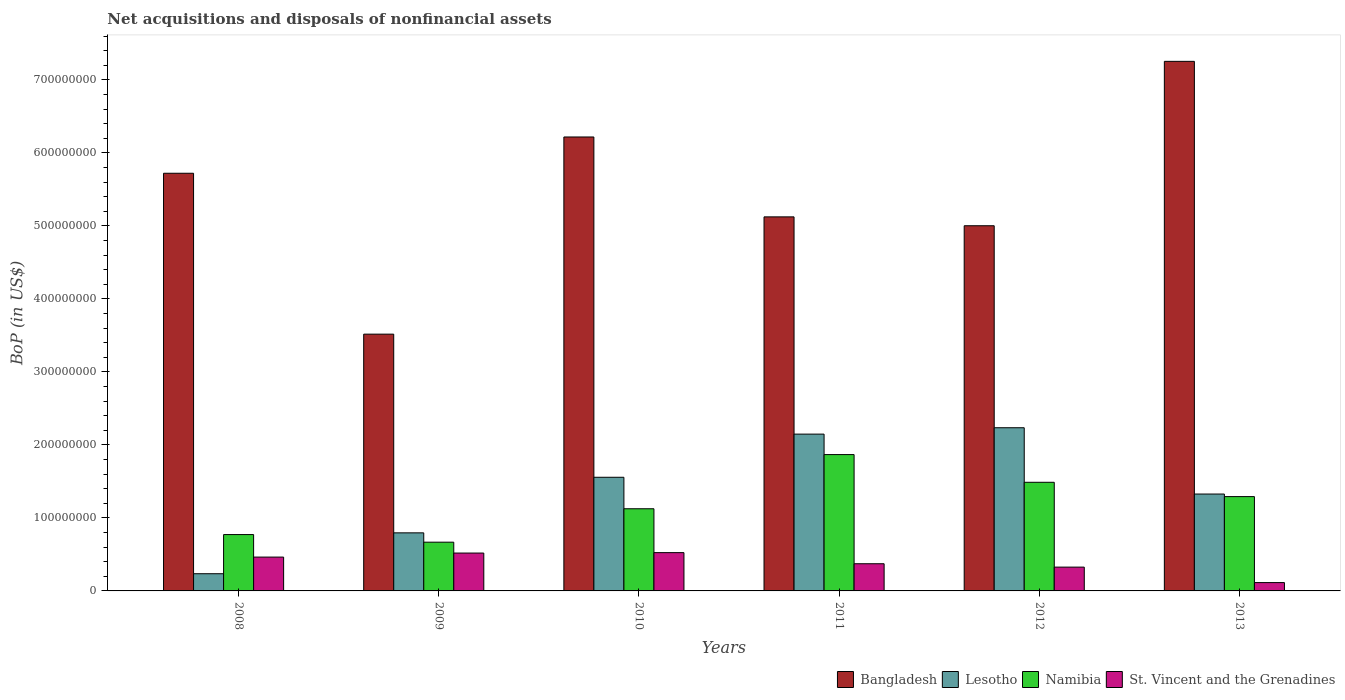How many different coloured bars are there?
Your answer should be very brief. 4. How many bars are there on the 4th tick from the left?
Provide a short and direct response. 4. What is the Balance of Payments in Bangladesh in 2009?
Give a very brief answer. 3.52e+08. Across all years, what is the maximum Balance of Payments in Bangladesh?
Your answer should be very brief. 7.25e+08. Across all years, what is the minimum Balance of Payments in St. Vincent and the Grenadines?
Your response must be concise. 1.14e+07. In which year was the Balance of Payments in St. Vincent and the Grenadines maximum?
Ensure brevity in your answer.  2010. What is the total Balance of Payments in Namibia in the graph?
Provide a short and direct response. 7.21e+08. What is the difference between the Balance of Payments in Bangladesh in 2011 and that in 2013?
Your answer should be very brief. -2.13e+08. What is the difference between the Balance of Payments in Namibia in 2011 and the Balance of Payments in Lesotho in 2012?
Ensure brevity in your answer.  -3.68e+07. What is the average Balance of Payments in Bangladesh per year?
Your response must be concise. 5.47e+08. In the year 2010, what is the difference between the Balance of Payments in Namibia and Balance of Payments in Lesotho?
Provide a succinct answer. -4.31e+07. In how many years, is the Balance of Payments in Lesotho greater than 620000000 US$?
Keep it short and to the point. 0. What is the ratio of the Balance of Payments in St. Vincent and the Grenadines in 2010 to that in 2011?
Offer a terse response. 1.41. Is the difference between the Balance of Payments in Namibia in 2009 and 2011 greater than the difference between the Balance of Payments in Lesotho in 2009 and 2011?
Give a very brief answer. Yes. What is the difference between the highest and the second highest Balance of Payments in St. Vincent and the Grenadines?
Offer a terse response. 5.84e+05. What is the difference between the highest and the lowest Balance of Payments in St. Vincent and the Grenadines?
Ensure brevity in your answer.  4.10e+07. In how many years, is the Balance of Payments in Lesotho greater than the average Balance of Payments in Lesotho taken over all years?
Your answer should be compact. 3. What does the 3rd bar from the left in 2013 represents?
Your answer should be very brief. Namibia. What does the 4th bar from the right in 2010 represents?
Give a very brief answer. Bangladesh. Are the values on the major ticks of Y-axis written in scientific E-notation?
Give a very brief answer. No. Does the graph contain grids?
Offer a terse response. No. How many legend labels are there?
Offer a very short reply. 4. How are the legend labels stacked?
Keep it short and to the point. Horizontal. What is the title of the graph?
Provide a short and direct response. Net acquisitions and disposals of nonfinancial assets. Does "Central African Republic" appear as one of the legend labels in the graph?
Your response must be concise. No. What is the label or title of the X-axis?
Give a very brief answer. Years. What is the label or title of the Y-axis?
Your answer should be very brief. BoP (in US$). What is the BoP (in US$) of Bangladesh in 2008?
Offer a terse response. 5.72e+08. What is the BoP (in US$) in Lesotho in 2008?
Your response must be concise. 2.36e+07. What is the BoP (in US$) in Namibia in 2008?
Provide a short and direct response. 7.72e+07. What is the BoP (in US$) in St. Vincent and the Grenadines in 2008?
Make the answer very short. 4.63e+07. What is the BoP (in US$) of Bangladesh in 2009?
Make the answer very short. 3.52e+08. What is the BoP (in US$) in Lesotho in 2009?
Make the answer very short. 7.96e+07. What is the BoP (in US$) of Namibia in 2009?
Keep it short and to the point. 6.68e+07. What is the BoP (in US$) in St. Vincent and the Grenadines in 2009?
Provide a short and direct response. 5.19e+07. What is the BoP (in US$) in Bangladesh in 2010?
Your answer should be compact. 6.22e+08. What is the BoP (in US$) in Lesotho in 2010?
Offer a very short reply. 1.56e+08. What is the BoP (in US$) in Namibia in 2010?
Offer a terse response. 1.13e+08. What is the BoP (in US$) in St. Vincent and the Grenadines in 2010?
Offer a terse response. 5.25e+07. What is the BoP (in US$) of Bangladesh in 2011?
Provide a short and direct response. 5.12e+08. What is the BoP (in US$) of Lesotho in 2011?
Your answer should be very brief. 2.15e+08. What is the BoP (in US$) of Namibia in 2011?
Your answer should be compact. 1.87e+08. What is the BoP (in US$) in St. Vincent and the Grenadines in 2011?
Your response must be concise. 3.72e+07. What is the BoP (in US$) in Bangladesh in 2012?
Make the answer very short. 5.00e+08. What is the BoP (in US$) in Lesotho in 2012?
Your answer should be compact. 2.24e+08. What is the BoP (in US$) in Namibia in 2012?
Your answer should be compact. 1.49e+08. What is the BoP (in US$) of St. Vincent and the Grenadines in 2012?
Provide a succinct answer. 3.26e+07. What is the BoP (in US$) of Bangladesh in 2013?
Your response must be concise. 7.25e+08. What is the BoP (in US$) of Lesotho in 2013?
Keep it short and to the point. 1.33e+08. What is the BoP (in US$) in Namibia in 2013?
Give a very brief answer. 1.29e+08. What is the BoP (in US$) of St. Vincent and the Grenadines in 2013?
Your response must be concise. 1.14e+07. Across all years, what is the maximum BoP (in US$) of Bangladesh?
Your answer should be very brief. 7.25e+08. Across all years, what is the maximum BoP (in US$) of Lesotho?
Offer a terse response. 2.24e+08. Across all years, what is the maximum BoP (in US$) of Namibia?
Keep it short and to the point. 1.87e+08. Across all years, what is the maximum BoP (in US$) in St. Vincent and the Grenadines?
Make the answer very short. 5.25e+07. Across all years, what is the minimum BoP (in US$) in Bangladesh?
Offer a very short reply. 3.52e+08. Across all years, what is the minimum BoP (in US$) of Lesotho?
Provide a short and direct response. 2.36e+07. Across all years, what is the minimum BoP (in US$) of Namibia?
Your response must be concise. 6.68e+07. Across all years, what is the minimum BoP (in US$) of St. Vincent and the Grenadines?
Provide a short and direct response. 1.14e+07. What is the total BoP (in US$) in Bangladesh in the graph?
Ensure brevity in your answer.  3.28e+09. What is the total BoP (in US$) of Lesotho in the graph?
Ensure brevity in your answer.  8.30e+08. What is the total BoP (in US$) of Namibia in the graph?
Give a very brief answer. 7.21e+08. What is the total BoP (in US$) of St. Vincent and the Grenadines in the graph?
Your answer should be compact. 2.32e+08. What is the difference between the BoP (in US$) of Bangladesh in 2008 and that in 2009?
Provide a short and direct response. 2.20e+08. What is the difference between the BoP (in US$) in Lesotho in 2008 and that in 2009?
Offer a terse response. -5.60e+07. What is the difference between the BoP (in US$) of Namibia in 2008 and that in 2009?
Your answer should be compact. 1.04e+07. What is the difference between the BoP (in US$) of St. Vincent and the Grenadines in 2008 and that in 2009?
Make the answer very short. -5.53e+06. What is the difference between the BoP (in US$) of Bangladesh in 2008 and that in 2010?
Keep it short and to the point. -4.97e+07. What is the difference between the BoP (in US$) in Lesotho in 2008 and that in 2010?
Provide a succinct answer. -1.32e+08. What is the difference between the BoP (in US$) in Namibia in 2008 and that in 2010?
Provide a short and direct response. -3.54e+07. What is the difference between the BoP (in US$) in St. Vincent and the Grenadines in 2008 and that in 2010?
Provide a succinct answer. -6.12e+06. What is the difference between the BoP (in US$) in Bangladesh in 2008 and that in 2011?
Give a very brief answer. 5.98e+07. What is the difference between the BoP (in US$) of Lesotho in 2008 and that in 2011?
Offer a very short reply. -1.91e+08. What is the difference between the BoP (in US$) of Namibia in 2008 and that in 2011?
Keep it short and to the point. -1.10e+08. What is the difference between the BoP (in US$) of St. Vincent and the Grenadines in 2008 and that in 2011?
Offer a very short reply. 9.11e+06. What is the difference between the BoP (in US$) in Bangladesh in 2008 and that in 2012?
Give a very brief answer. 7.19e+07. What is the difference between the BoP (in US$) of Lesotho in 2008 and that in 2012?
Make the answer very short. -2.00e+08. What is the difference between the BoP (in US$) in Namibia in 2008 and that in 2012?
Your answer should be compact. -7.16e+07. What is the difference between the BoP (in US$) of St. Vincent and the Grenadines in 2008 and that in 2012?
Keep it short and to the point. 1.37e+07. What is the difference between the BoP (in US$) of Bangladesh in 2008 and that in 2013?
Give a very brief answer. -1.53e+08. What is the difference between the BoP (in US$) in Lesotho in 2008 and that in 2013?
Provide a succinct answer. -1.09e+08. What is the difference between the BoP (in US$) of Namibia in 2008 and that in 2013?
Make the answer very short. -5.20e+07. What is the difference between the BoP (in US$) of St. Vincent and the Grenadines in 2008 and that in 2013?
Provide a short and direct response. 3.49e+07. What is the difference between the BoP (in US$) in Bangladesh in 2009 and that in 2010?
Give a very brief answer. -2.70e+08. What is the difference between the BoP (in US$) of Lesotho in 2009 and that in 2010?
Your response must be concise. -7.61e+07. What is the difference between the BoP (in US$) of Namibia in 2009 and that in 2010?
Your response must be concise. -4.58e+07. What is the difference between the BoP (in US$) of St. Vincent and the Grenadines in 2009 and that in 2010?
Make the answer very short. -5.84e+05. What is the difference between the BoP (in US$) in Bangladesh in 2009 and that in 2011?
Your response must be concise. -1.61e+08. What is the difference between the BoP (in US$) in Lesotho in 2009 and that in 2011?
Provide a short and direct response. -1.35e+08. What is the difference between the BoP (in US$) in Namibia in 2009 and that in 2011?
Make the answer very short. -1.20e+08. What is the difference between the BoP (in US$) of St. Vincent and the Grenadines in 2009 and that in 2011?
Make the answer very short. 1.46e+07. What is the difference between the BoP (in US$) of Bangladesh in 2009 and that in 2012?
Give a very brief answer. -1.48e+08. What is the difference between the BoP (in US$) in Lesotho in 2009 and that in 2012?
Make the answer very short. -1.44e+08. What is the difference between the BoP (in US$) in Namibia in 2009 and that in 2012?
Keep it short and to the point. -8.21e+07. What is the difference between the BoP (in US$) of St. Vincent and the Grenadines in 2009 and that in 2012?
Give a very brief answer. 1.93e+07. What is the difference between the BoP (in US$) in Bangladesh in 2009 and that in 2013?
Provide a short and direct response. -3.74e+08. What is the difference between the BoP (in US$) in Lesotho in 2009 and that in 2013?
Your answer should be very brief. -5.32e+07. What is the difference between the BoP (in US$) in Namibia in 2009 and that in 2013?
Provide a short and direct response. -6.24e+07. What is the difference between the BoP (in US$) in St. Vincent and the Grenadines in 2009 and that in 2013?
Your answer should be very brief. 4.05e+07. What is the difference between the BoP (in US$) in Bangladesh in 2010 and that in 2011?
Provide a succinct answer. 1.09e+08. What is the difference between the BoP (in US$) of Lesotho in 2010 and that in 2011?
Keep it short and to the point. -5.91e+07. What is the difference between the BoP (in US$) in Namibia in 2010 and that in 2011?
Offer a terse response. -7.42e+07. What is the difference between the BoP (in US$) in St. Vincent and the Grenadines in 2010 and that in 2011?
Make the answer very short. 1.52e+07. What is the difference between the BoP (in US$) in Bangladesh in 2010 and that in 2012?
Keep it short and to the point. 1.22e+08. What is the difference between the BoP (in US$) in Lesotho in 2010 and that in 2012?
Keep it short and to the point. -6.79e+07. What is the difference between the BoP (in US$) in Namibia in 2010 and that in 2012?
Offer a very short reply. -3.63e+07. What is the difference between the BoP (in US$) of St. Vincent and the Grenadines in 2010 and that in 2012?
Your answer should be compact. 1.98e+07. What is the difference between the BoP (in US$) in Bangladesh in 2010 and that in 2013?
Make the answer very short. -1.04e+08. What is the difference between the BoP (in US$) of Lesotho in 2010 and that in 2013?
Offer a terse response. 2.30e+07. What is the difference between the BoP (in US$) of Namibia in 2010 and that in 2013?
Give a very brief answer. -1.66e+07. What is the difference between the BoP (in US$) in St. Vincent and the Grenadines in 2010 and that in 2013?
Provide a succinct answer. 4.10e+07. What is the difference between the BoP (in US$) of Bangladesh in 2011 and that in 2012?
Your answer should be very brief. 1.21e+07. What is the difference between the BoP (in US$) of Lesotho in 2011 and that in 2012?
Your answer should be compact. -8.74e+06. What is the difference between the BoP (in US$) of Namibia in 2011 and that in 2012?
Keep it short and to the point. 3.79e+07. What is the difference between the BoP (in US$) in St. Vincent and the Grenadines in 2011 and that in 2012?
Make the answer very short. 4.62e+06. What is the difference between the BoP (in US$) in Bangladesh in 2011 and that in 2013?
Your answer should be very brief. -2.13e+08. What is the difference between the BoP (in US$) in Lesotho in 2011 and that in 2013?
Keep it short and to the point. 8.21e+07. What is the difference between the BoP (in US$) of Namibia in 2011 and that in 2013?
Offer a terse response. 5.76e+07. What is the difference between the BoP (in US$) of St. Vincent and the Grenadines in 2011 and that in 2013?
Keep it short and to the point. 2.58e+07. What is the difference between the BoP (in US$) of Bangladesh in 2012 and that in 2013?
Offer a terse response. -2.25e+08. What is the difference between the BoP (in US$) of Lesotho in 2012 and that in 2013?
Keep it short and to the point. 9.08e+07. What is the difference between the BoP (in US$) in Namibia in 2012 and that in 2013?
Your answer should be very brief. 1.96e+07. What is the difference between the BoP (in US$) in St. Vincent and the Grenadines in 2012 and that in 2013?
Give a very brief answer. 2.12e+07. What is the difference between the BoP (in US$) in Bangladesh in 2008 and the BoP (in US$) in Lesotho in 2009?
Your answer should be compact. 4.93e+08. What is the difference between the BoP (in US$) of Bangladesh in 2008 and the BoP (in US$) of Namibia in 2009?
Keep it short and to the point. 5.05e+08. What is the difference between the BoP (in US$) in Bangladesh in 2008 and the BoP (in US$) in St. Vincent and the Grenadines in 2009?
Offer a very short reply. 5.20e+08. What is the difference between the BoP (in US$) of Lesotho in 2008 and the BoP (in US$) of Namibia in 2009?
Offer a terse response. -4.32e+07. What is the difference between the BoP (in US$) in Lesotho in 2008 and the BoP (in US$) in St. Vincent and the Grenadines in 2009?
Make the answer very short. -2.83e+07. What is the difference between the BoP (in US$) of Namibia in 2008 and the BoP (in US$) of St. Vincent and the Grenadines in 2009?
Offer a very short reply. 2.53e+07. What is the difference between the BoP (in US$) in Bangladesh in 2008 and the BoP (in US$) in Lesotho in 2010?
Your answer should be compact. 4.16e+08. What is the difference between the BoP (in US$) in Bangladesh in 2008 and the BoP (in US$) in Namibia in 2010?
Provide a succinct answer. 4.60e+08. What is the difference between the BoP (in US$) in Bangladesh in 2008 and the BoP (in US$) in St. Vincent and the Grenadines in 2010?
Offer a very short reply. 5.20e+08. What is the difference between the BoP (in US$) of Lesotho in 2008 and the BoP (in US$) of Namibia in 2010?
Offer a terse response. -8.90e+07. What is the difference between the BoP (in US$) in Lesotho in 2008 and the BoP (in US$) in St. Vincent and the Grenadines in 2010?
Your response must be concise. -2.89e+07. What is the difference between the BoP (in US$) of Namibia in 2008 and the BoP (in US$) of St. Vincent and the Grenadines in 2010?
Give a very brief answer. 2.47e+07. What is the difference between the BoP (in US$) of Bangladesh in 2008 and the BoP (in US$) of Lesotho in 2011?
Offer a terse response. 3.57e+08. What is the difference between the BoP (in US$) of Bangladesh in 2008 and the BoP (in US$) of Namibia in 2011?
Your answer should be compact. 3.85e+08. What is the difference between the BoP (in US$) in Bangladesh in 2008 and the BoP (in US$) in St. Vincent and the Grenadines in 2011?
Offer a very short reply. 5.35e+08. What is the difference between the BoP (in US$) in Lesotho in 2008 and the BoP (in US$) in Namibia in 2011?
Your answer should be very brief. -1.63e+08. What is the difference between the BoP (in US$) of Lesotho in 2008 and the BoP (in US$) of St. Vincent and the Grenadines in 2011?
Provide a short and direct response. -1.37e+07. What is the difference between the BoP (in US$) of Namibia in 2008 and the BoP (in US$) of St. Vincent and the Grenadines in 2011?
Keep it short and to the point. 4.00e+07. What is the difference between the BoP (in US$) of Bangladesh in 2008 and the BoP (in US$) of Lesotho in 2012?
Provide a short and direct response. 3.49e+08. What is the difference between the BoP (in US$) of Bangladesh in 2008 and the BoP (in US$) of Namibia in 2012?
Your answer should be very brief. 4.23e+08. What is the difference between the BoP (in US$) in Bangladesh in 2008 and the BoP (in US$) in St. Vincent and the Grenadines in 2012?
Offer a very short reply. 5.40e+08. What is the difference between the BoP (in US$) in Lesotho in 2008 and the BoP (in US$) in Namibia in 2012?
Make the answer very short. -1.25e+08. What is the difference between the BoP (in US$) in Lesotho in 2008 and the BoP (in US$) in St. Vincent and the Grenadines in 2012?
Offer a terse response. -9.06e+06. What is the difference between the BoP (in US$) in Namibia in 2008 and the BoP (in US$) in St. Vincent and the Grenadines in 2012?
Ensure brevity in your answer.  4.46e+07. What is the difference between the BoP (in US$) of Bangladesh in 2008 and the BoP (in US$) of Lesotho in 2013?
Provide a succinct answer. 4.39e+08. What is the difference between the BoP (in US$) in Bangladesh in 2008 and the BoP (in US$) in Namibia in 2013?
Your answer should be compact. 4.43e+08. What is the difference between the BoP (in US$) of Bangladesh in 2008 and the BoP (in US$) of St. Vincent and the Grenadines in 2013?
Your answer should be compact. 5.61e+08. What is the difference between the BoP (in US$) in Lesotho in 2008 and the BoP (in US$) in Namibia in 2013?
Provide a succinct answer. -1.06e+08. What is the difference between the BoP (in US$) of Lesotho in 2008 and the BoP (in US$) of St. Vincent and the Grenadines in 2013?
Your answer should be very brief. 1.21e+07. What is the difference between the BoP (in US$) of Namibia in 2008 and the BoP (in US$) of St. Vincent and the Grenadines in 2013?
Your answer should be very brief. 6.58e+07. What is the difference between the BoP (in US$) of Bangladesh in 2009 and the BoP (in US$) of Lesotho in 2010?
Give a very brief answer. 1.96e+08. What is the difference between the BoP (in US$) of Bangladesh in 2009 and the BoP (in US$) of Namibia in 2010?
Provide a short and direct response. 2.39e+08. What is the difference between the BoP (in US$) of Bangladesh in 2009 and the BoP (in US$) of St. Vincent and the Grenadines in 2010?
Your answer should be compact. 2.99e+08. What is the difference between the BoP (in US$) in Lesotho in 2009 and the BoP (in US$) in Namibia in 2010?
Provide a succinct answer. -3.30e+07. What is the difference between the BoP (in US$) of Lesotho in 2009 and the BoP (in US$) of St. Vincent and the Grenadines in 2010?
Your response must be concise. 2.71e+07. What is the difference between the BoP (in US$) in Namibia in 2009 and the BoP (in US$) in St. Vincent and the Grenadines in 2010?
Ensure brevity in your answer.  1.43e+07. What is the difference between the BoP (in US$) of Bangladesh in 2009 and the BoP (in US$) of Lesotho in 2011?
Make the answer very short. 1.37e+08. What is the difference between the BoP (in US$) in Bangladesh in 2009 and the BoP (in US$) in Namibia in 2011?
Offer a very short reply. 1.65e+08. What is the difference between the BoP (in US$) in Bangladesh in 2009 and the BoP (in US$) in St. Vincent and the Grenadines in 2011?
Offer a terse response. 3.15e+08. What is the difference between the BoP (in US$) of Lesotho in 2009 and the BoP (in US$) of Namibia in 2011?
Keep it short and to the point. -1.07e+08. What is the difference between the BoP (in US$) in Lesotho in 2009 and the BoP (in US$) in St. Vincent and the Grenadines in 2011?
Make the answer very short. 4.23e+07. What is the difference between the BoP (in US$) of Namibia in 2009 and the BoP (in US$) of St. Vincent and the Grenadines in 2011?
Offer a very short reply. 2.95e+07. What is the difference between the BoP (in US$) of Bangladesh in 2009 and the BoP (in US$) of Lesotho in 2012?
Provide a short and direct response. 1.28e+08. What is the difference between the BoP (in US$) in Bangladesh in 2009 and the BoP (in US$) in Namibia in 2012?
Provide a succinct answer. 2.03e+08. What is the difference between the BoP (in US$) in Bangladesh in 2009 and the BoP (in US$) in St. Vincent and the Grenadines in 2012?
Offer a very short reply. 3.19e+08. What is the difference between the BoP (in US$) in Lesotho in 2009 and the BoP (in US$) in Namibia in 2012?
Offer a terse response. -6.93e+07. What is the difference between the BoP (in US$) of Lesotho in 2009 and the BoP (in US$) of St. Vincent and the Grenadines in 2012?
Keep it short and to the point. 4.69e+07. What is the difference between the BoP (in US$) in Namibia in 2009 and the BoP (in US$) in St. Vincent and the Grenadines in 2012?
Give a very brief answer. 3.42e+07. What is the difference between the BoP (in US$) in Bangladesh in 2009 and the BoP (in US$) in Lesotho in 2013?
Provide a succinct answer. 2.19e+08. What is the difference between the BoP (in US$) of Bangladesh in 2009 and the BoP (in US$) of Namibia in 2013?
Keep it short and to the point. 2.23e+08. What is the difference between the BoP (in US$) in Bangladesh in 2009 and the BoP (in US$) in St. Vincent and the Grenadines in 2013?
Keep it short and to the point. 3.40e+08. What is the difference between the BoP (in US$) of Lesotho in 2009 and the BoP (in US$) of Namibia in 2013?
Ensure brevity in your answer.  -4.97e+07. What is the difference between the BoP (in US$) in Lesotho in 2009 and the BoP (in US$) in St. Vincent and the Grenadines in 2013?
Provide a succinct answer. 6.81e+07. What is the difference between the BoP (in US$) of Namibia in 2009 and the BoP (in US$) of St. Vincent and the Grenadines in 2013?
Provide a short and direct response. 5.54e+07. What is the difference between the BoP (in US$) of Bangladesh in 2010 and the BoP (in US$) of Lesotho in 2011?
Ensure brevity in your answer.  4.07e+08. What is the difference between the BoP (in US$) of Bangladesh in 2010 and the BoP (in US$) of Namibia in 2011?
Provide a short and direct response. 4.35e+08. What is the difference between the BoP (in US$) of Bangladesh in 2010 and the BoP (in US$) of St. Vincent and the Grenadines in 2011?
Make the answer very short. 5.85e+08. What is the difference between the BoP (in US$) in Lesotho in 2010 and the BoP (in US$) in Namibia in 2011?
Provide a short and direct response. -3.11e+07. What is the difference between the BoP (in US$) in Lesotho in 2010 and the BoP (in US$) in St. Vincent and the Grenadines in 2011?
Your response must be concise. 1.18e+08. What is the difference between the BoP (in US$) in Namibia in 2010 and the BoP (in US$) in St. Vincent and the Grenadines in 2011?
Offer a terse response. 7.53e+07. What is the difference between the BoP (in US$) of Bangladesh in 2010 and the BoP (in US$) of Lesotho in 2012?
Offer a very short reply. 3.98e+08. What is the difference between the BoP (in US$) in Bangladesh in 2010 and the BoP (in US$) in Namibia in 2012?
Offer a very short reply. 4.73e+08. What is the difference between the BoP (in US$) in Bangladesh in 2010 and the BoP (in US$) in St. Vincent and the Grenadines in 2012?
Offer a terse response. 5.89e+08. What is the difference between the BoP (in US$) of Lesotho in 2010 and the BoP (in US$) of Namibia in 2012?
Provide a succinct answer. 6.85e+06. What is the difference between the BoP (in US$) of Lesotho in 2010 and the BoP (in US$) of St. Vincent and the Grenadines in 2012?
Offer a terse response. 1.23e+08. What is the difference between the BoP (in US$) of Namibia in 2010 and the BoP (in US$) of St. Vincent and the Grenadines in 2012?
Your answer should be compact. 7.99e+07. What is the difference between the BoP (in US$) of Bangladesh in 2010 and the BoP (in US$) of Lesotho in 2013?
Provide a short and direct response. 4.89e+08. What is the difference between the BoP (in US$) of Bangladesh in 2010 and the BoP (in US$) of Namibia in 2013?
Your answer should be very brief. 4.93e+08. What is the difference between the BoP (in US$) of Bangladesh in 2010 and the BoP (in US$) of St. Vincent and the Grenadines in 2013?
Offer a terse response. 6.10e+08. What is the difference between the BoP (in US$) of Lesotho in 2010 and the BoP (in US$) of Namibia in 2013?
Make the answer very short. 2.65e+07. What is the difference between the BoP (in US$) of Lesotho in 2010 and the BoP (in US$) of St. Vincent and the Grenadines in 2013?
Your response must be concise. 1.44e+08. What is the difference between the BoP (in US$) of Namibia in 2010 and the BoP (in US$) of St. Vincent and the Grenadines in 2013?
Your answer should be compact. 1.01e+08. What is the difference between the BoP (in US$) of Bangladesh in 2011 and the BoP (in US$) of Lesotho in 2012?
Provide a succinct answer. 2.89e+08. What is the difference between the BoP (in US$) of Bangladesh in 2011 and the BoP (in US$) of Namibia in 2012?
Your answer should be very brief. 3.64e+08. What is the difference between the BoP (in US$) of Bangladesh in 2011 and the BoP (in US$) of St. Vincent and the Grenadines in 2012?
Provide a short and direct response. 4.80e+08. What is the difference between the BoP (in US$) in Lesotho in 2011 and the BoP (in US$) in Namibia in 2012?
Keep it short and to the point. 6.60e+07. What is the difference between the BoP (in US$) of Lesotho in 2011 and the BoP (in US$) of St. Vincent and the Grenadines in 2012?
Keep it short and to the point. 1.82e+08. What is the difference between the BoP (in US$) of Namibia in 2011 and the BoP (in US$) of St. Vincent and the Grenadines in 2012?
Your answer should be compact. 1.54e+08. What is the difference between the BoP (in US$) in Bangladesh in 2011 and the BoP (in US$) in Lesotho in 2013?
Keep it short and to the point. 3.80e+08. What is the difference between the BoP (in US$) in Bangladesh in 2011 and the BoP (in US$) in Namibia in 2013?
Keep it short and to the point. 3.83e+08. What is the difference between the BoP (in US$) in Bangladesh in 2011 and the BoP (in US$) in St. Vincent and the Grenadines in 2013?
Provide a short and direct response. 5.01e+08. What is the difference between the BoP (in US$) in Lesotho in 2011 and the BoP (in US$) in Namibia in 2013?
Ensure brevity in your answer.  8.56e+07. What is the difference between the BoP (in US$) in Lesotho in 2011 and the BoP (in US$) in St. Vincent and the Grenadines in 2013?
Make the answer very short. 2.03e+08. What is the difference between the BoP (in US$) of Namibia in 2011 and the BoP (in US$) of St. Vincent and the Grenadines in 2013?
Give a very brief answer. 1.75e+08. What is the difference between the BoP (in US$) in Bangladesh in 2012 and the BoP (in US$) in Lesotho in 2013?
Offer a very short reply. 3.68e+08. What is the difference between the BoP (in US$) in Bangladesh in 2012 and the BoP (in US$) in Namibia in 2013?
Provide a short and direct response. 3.71e+08. What is the difference between the BoP (in US$) in Bangladesh in 2012 and the BoP (in US$) in St. Vincent and the Grenadines in 2013?
Offer a terse response. 4.89e+08. What is the difference between the BoP (in US$) of Lesotho in 2012 and the BoP (in US$) of Namibia in 2013?
Your answer should be compact. 9.43e+07. What is the difference between the BoP (in US$) of Lesotho in 2012 and the BoP (in US$) of St. Vincent and the Grenadines in 2013?
Your answer should be compact. 2.12e+08. What is the difference between the BoP (in US$) of Namibia in 2012 and the BoP (in US$) of St. Vincent and the Grenadines in 2013?
Ensure brevity in your answer.  1.37e+08. What is the average BoP (in US$) of Bangladesh per year?
Provide a short and direct response. 5.47e+08. What is the average BoP (in US$) of Lesotho per year?
Give a very brief answer. 1.38e+08. What is the average BoP (in US$) of Namibia per year?
Give a very brief answer. 1.20e+08. What is the average BoP (in US$) in St. Vincent and the Grenadines per year?
Make the answer very short. 3.87e+07. In the year 2008, what is the difference between the BoP (in US$) in Bangladesh and BoP (in US$) in Lesotho?
Ensure brevity in your answer.  5.49e+08. In the year 2008, what is the difference between the BoP (in US$) of Bangladesh and BoP (in US$) of Namibia?
Give a very brief answer. 4.95e+08. In the year 2008, what is the difference between the BoP (in US$) of Bangladesh and BoP (in US$) of St. Vincent and the Grenadines?
Your response must be concise. 5.26e+08. In the year 2008, what is the difference between the BoP (in US$) in Lesotho and BoP (in US$) in Namibia?
Give a very brief answer. -5.36e+07. In the year 2008, what is the difference between the BoP (in US$) of Lesotho and BoP (in US$) of St. Vincent and the Grenadines?
Your answer should be very brief. -2.28e+07. In the year 2008, what is the difference between the BoP (in US$) of Namibia and BoP (in US$) of St. Vincent and the Grenadines?
Offer a terse response. 3.09e+07. In the year 2009, what is the difference between the BoP (in US$) of Bangladesh and BoP (in US$) of Lesotho?
Offer a very short reply. 2.72e+08. In the year 2009, what is the difference between the BoP (in US$) in Bangladesh and BoP (in US$) in Namibia?
Your answer should be very brief. 2.85e+08. In the year 2009, what is the difference between the BoP (in US$) of Bangladesh and BoP (in US$) of St. Vincent and the Grenadines?
Provide a succinct answer. 3.00e+08. In the year 2009, what is the difference between the BoP (in US$) of Lesotho and BoP (in US$) of Namibia?
Provide a succinct answer. 1.28e+07. In the year 2009, what is the difference between the BoP (in US$) in Lesotho and BoP (in US$) in St. Vincent and the Grenadines?
Make the answer very short. 2.77e+07. In the year 2009, what is the difference between the BoP (in US$) in Namibia and BoP (in US$) in St. Vincent and the Grenadines?
Offer a terse response. 1.49e+07. In the year 2010, what is the difference between the BoP (in US$) of Bangladesh and BoP (in US$) of Lesotho?
Keep it short and to the point. 4.66e+08. In the year 2010, what is the difference between the BoP (in US$) of Bangladesh and BoP (in US$) of Namibia?
Give a very brief answer. 5.09e+08. In the year 2010, what is the difference between the BoP (in US$) of Bangladesh and BoP (in US$) of St. Vincent and the Grenadines?
Give a very brief answer. 5.69e+08. In the year 2010, what is the difference between the BoP (in US$) in Lesotho and BoP (in US$) in Namibia?
Your answer should be very brief. 4.31e+07. In the year 2010, what is the difference between the BoP (in US$) of Lesotho and BoP (in US$) of St. Vincent and the Grenadines?
Your answer should be very brief. 1.03e+08. In the year 2010, what is the difference between the BoP (in US$) in Namibia and BoP (in US$) in St. Vincent and the Grenadines?
Offer a very short reply. 6.01e+07. In the year 2011, what is the difference between the BoP (in US$) of Bangladesh and BoP (in US$) of Lesotho?
Your response must be concise. 2.98e+08. In the year 2011, what is the difference between the BoP (in US$) in Bangladesh and BoP (in US$) in Namibia?
Ensure brevity in your answer.  3.26e+08. In the year 2011, what is the difference between the BoP (in US$) of Bangladesh and BoP (in US$) of St. Vincent and the Grenadines?
Make the answer very short. 4.75e+08. In the year 2011, what is the difference between the BoP (in US$) of Lesotho and BoP (in US$) of Namibia?
Ensure brevity in your answer.  2.80e+07. In the year 2011, what is the difference between the BoP (in US$) in Lesotho and BoP (in US$) in St. Vincent and the Grenadines?
Keep it short and to the point. 1.78e+08. In the year 2011, what is the difference between the BoP (in US$) of Namibia and BoP (in US$) of St. Vincent and the Grenadines?
Your answer should be very brief. 1.50e+08. In the year 2012, what is the difference between the BoP (in US$) in Bangladesh and BoP (in US$) in Lesotho?
Provide a succinct answer. 2.77e+08. In the year 2012, what is the difference between the BoP (in US$) in Bangladesh and BoP (in US$) in Namibia?
Your answer should be compact. 3.51e+08. In the year 2012, what is the difference between the BoP (in US$) of Bangladesh and BoP (in US$) of St. Vincent and the Grenadines?
Offer a very short reply. 4.68e+08. In the year 2012, what is the difference between the BoP (in US$) of Lesotho and BoP (in US$) of Namibia?
Provide a short and direct response. 7.47e+07. In the year 2012, what is the difference between the BoP (in US$) of Lesotho and BoP (in US$) of St. Vincent and the Grenadines?
Make the answer very short. 1.91e+08. In the year 2012, what is the difference between the BoP (in US$) of Namibia and BoP (in US$) of St. Vincent and the Grenadines?
Your answer should be compact. 1.16e+08. In the year 2013, what is the difference between the BoP (in US$) of Bangladesh and BoP (in US$) of Lesotho?
Your answer should be very brief. 5.93e+08. In the year 2013, what is the difference between the BoP (in US$) in Bangladesh and BoP (in US$) in Namibia?
Make the answer very short. 5.96e+08. In the year 2013, what is the difference between the BoP (in US$) of Bangladesh and BoP (in US$) of St. Vincent and the Grenadines?
Your answer should be very brief. 7.14e+08. In the year 2013, what is the difference between the BoP (in US$) in Lesotho and BoP (in US$) in Namibia?
Your answer should be very brief. 3.50e+06. In the year 2013, what is the difference between the BoP (in US$) of Lesotho and BoP (in US$) of St. Vincent and the Grenadines?
Your answer should be very brief. 1.21e+08. In the year 2013, what is the difference between the BoP (in US$) of Namibia and BoP (in US$) of St. Vincent and the Grenadines?
Offer a terse response. 1.18e+08. What is the ratio of the BoP (in US$) of Bangladesh in 2008 to that in 2009?
Offer a very short reply. 1.63. What is the ratio of the BoP (in US$) of Lesotho in 2008 to that in 2009?
Your answer should be very brief. 0.3. What is the ratio of the BoP (in US$) of Namibia in 2008 to that in 2009?
Ensure brevity in your answer.  1.16. What is the ratio of the BoP (in US$) in St. Vincent and the Grenadines in 2008 to that in 2009?
Offer a very short reply. 0.89. What is the ratio of the BoP (in US$) in Bangladesh in 2008 to that in 2010?
Keep it short and to the point. 0.92. What is the ratio of the BoP (in US$) of Lesotho in 2008 to that in 2010?
Offer a terse response. 0.15. What is the ratio of the BoP (in US$) of Namibia in 2008 to that in 2010?
Your response must be concise. 0.69. What is the ratio of the BoP (in US$) of St. Vincent and the Grenadines in 2008 to that in 2010?
Provide a short and direct response. 0.88. What is the ratio of the BoP (in US$) of Bangladesh in 2008 to that in 2011?
Keep it short and to the point. 1.12. What is the ratio of the BoP (in US$) of Lesotho in 2008 to that in 2011?
Your response must be concise. 0.11. What is the ratio of the BoP (in US$) in Namibia in 2008 to that in 2011?
Keep it short and to the point. 0.41. What is the ratio of the BoP (in US$) of St. Vincent and the Grenadines in 2008 to that in 2011?
Your answer should be very brief. 1.24. What is the ratio of the BoP (in US$) in Bangladesh in 2008 to that in 2012?
Offer a very short reply. 1.14. What is the ratio of the BoP (in US$) in Lesotho in 2008 to that in 2012?
Ensure brevity in your answer.  0.11. What is the ratio of the BoP (in US$) in Namibia in 2008 to that in 2012?
Ensure brevity in your answer.  0.52. What is the ratio of the BoP (in US$) in St. Vincent and the Grenadines in 2008 to that in 2012?
Ensure brevity in your answer.  1.42. What is the ratio of the BoP (in US$) in Bangladesh in 2008 to that in 2013?
Offer a very short reply. 0.79. What is the ratio of the BoP (in US$) of Lesotho in 2008 to that in 2013?
Offer a terse response. 0.18. What is the ratio of the BoP (in US$) in Namibia in 2008 to that in 2013?
Your answer should be very brief. 0.6. What is the ratio of the BoP (in US$) in St. Vincent and the Grenadines in 2008 to that in 2013?
Make the answer very short. 4.06. What is the ratio of the BoP (in US$) in Bangladesh in 2009 to that in 2010?
Give a very brief answer. 0.57. What is the ratio of the BoP (in US$) of Lesotho in 2009 to that in 2010?
Provide a short and direct response. 0.51. What is the ratio of the BoP (in US$) of Namibia in 2009 to that in 2010?
Your answer should be compact. 0.59. What is the ratio of the BoP (in US$) of St. Vincent and the Grenadines in 2009 to that in 2010?
Give a very brief answer. 0.99. What is the ratio of the BoP (in US$) of Bangladesh in 2009 to that in 2011?
Your answer should be very brief. 0.69. What is the ratio of the BoP (in US$) of Lesotho in 2009 to that in 2011?
Keep it short and to the point. 0.37. What is the ratio of the BoP (in US$) in Namibia in 2009 to that in 2011?
Your response must be concise. 0.36. What is the ratio of the BoP (in US$) in St. Vincent and the Grenadines in 2009 to that in 2011?
Make the answer very short. 1.39. What is the ratio of the BoP (in US$) in Bangladesh in 2009 to that in 2012?
Provide a short and direct response. 0.7. What is the ratio of the BoP (in US$) in Lesotho in 2009 to that in 2012?
Ensure brevity in your answer.  0.36. What is the ratio of the BoP (in US$) in Namibia in 2009 to that in 2012?
Offer a terse response. 0.45. What is the ratio of the BoP (in US$) in St. Vincent and the Grenadines in 2009 to that in 2012?
Your response must be concise. 1.59. What is the ratio of the BoP (in US$) in Bangladesh in 2009 to that in 2013?
Ensure brevity in your answer.  0.48. What is the ratio of the BoP (in US$) in Lesotho in 2009 to that in 2013?
Your answer should be compact. 0.6. What is the ratio of the BoP (in US$) in Namibia in 2009 to that in 2013?
Give a very brief answer. 0.52. What is the ratio of the BoP (in US$) of St. Vincent and the Grenadines in 2009 to that in 2013?
Make the answer very short. 4.54. What is the ratio of the BoP (in US$) of Bangladesh in 2010 to that in 2011?
Your response must be concise. 1.21. What is the ratio of the BoP (in US$) in Lesotho in 2010 to that in 2011?
Offer a terse response. 0.72. What is the ratio of the BoP (in US$) in Namibia in 2010 to that in 2011?
Keep it short and to the point. 0.6. What is the ratio of the BoP (in US$) in St. Vincent and the Grenadines in 2010 to that in 2011?
Offer a very short reply. 1.41. What is the ratio of the BoP (in US$) of Bangladesh in 2010 to that in 2012?
Your answer should be very brief. 1.24. What is the ratio of the BoP (in US$) of Lesotho in 2010 to that in 2012?
Offer a terse response. 0.7. What is the ratio of the BoP (in US$) in Namibia in 2010 to that in 2012?
Offer a very short reply. 0.76. What is the ratio of the BoP (in US$) of St. Vincent and the Grenadines in 2010 to that in 2012?
Your response must be concise. 1.61. What is the ratio of the BoP (in US$) of Bangladesh in 2010 to that in 2013?
Provide a short and direct response. 0.86. What is the ratio of the BoP (in US$) of Lesotho in 2010 to that in 2013?
Give a very brief answer. 1.17. What is the ratio of the BoP (in US$) of Namibia in 2010 to that in 2013?
Ensure brevity in your answer.  0.87. What is the ratio of the BoP (in US$) of St. Vincent and the Grenadines in 2010 to that in 2013?
Make the answer very short. 4.6. What is the ratio of the BoP (in US$) in Bangladesh in 2011 to that in 2012?
Give a very brief answer. 1.02. What is the ratio of the BoP (in US$) in Lesotho in 2011 to that in 2012?
Provide a short and direct response. 0.96. What is the ratio of the BoP (in US$) of Namibia in 2011 to that in 2012?
Provide a succinct answer. 1.25. What is the ratio of the BoP (in US$) of St. Vincent and the Grenadines in 2011 to that in 2012?
Give a very brief answer. 1.14. What is the ratio of the BoP (in US$) of Bangladesh in 2011 to that in 2013?
Provide a short and direct response. 0.71. What is the ratio of the BoP (in US$) in Lesotho in 2011 to that in 2013?
Keep it short and to the point. 1.62. What is the ratio of the BoP (in US$) in Namibia in 2011 to that in 2013?
Your answer should be very brief. 1.45. What is the ratio of the BoP (in US$) in St. Vincent and the Grenadines in 2011 to that in 2013?
Give a very brief answer. 3.26. What is the ratio of the BoP (in US$) of Bangladesh in 2012 to that in 2013?
Your response must be concise. 0.69. What is the ratio of the BoP (in US$) in Lesotho in 2012 to that in 2013?
Provide a short and direct response. 1.68. What is the ratio of the BoP (in US$) of Namibia in 2012 to that in 2013?
Provide a short and direct response. 1.15. What is the ratio of the BoP (in US$) of St. Vincent and the Grenadines in 2012 to that in 2013?
Your response must be concise. 2.86. What is the difference between the highest and the second highest BoP (in US$) of Bangladesh?
Ensure brevity in your answer.  1.04e+08. What is the difference between the highest and the second highest BoP (in US$) in Lesotho?
Your answer should be compact. 8.74e+06. What is the difference between the highest and the second highest BoP (in US$) of Namibia?
Your response must be concise. 3.79e+07. What is the difference between the highest and the second highest BoP (in US$) of St. Vincent and the Grenadines?
Your response must be concise. 5.84e+05. What is the difference between the highest and the lowest BoP (in US$) of Bangladesh?
Your response must be concise. 3.74e+08. What is the difference between the highest and the lowest BoP (in US$) of Lesotho?
Your answer should be compact. 2.00e+08. What is the difference between the highest and the lowest BoP (in US$) of Namibia?
Make the answer very short. 1.20e+08. What is the difference between the highest and the lowest BoP (in US$) of St. Vincent and the Grenadines?
Ensure brevity in your answer.  4.10e+07. 